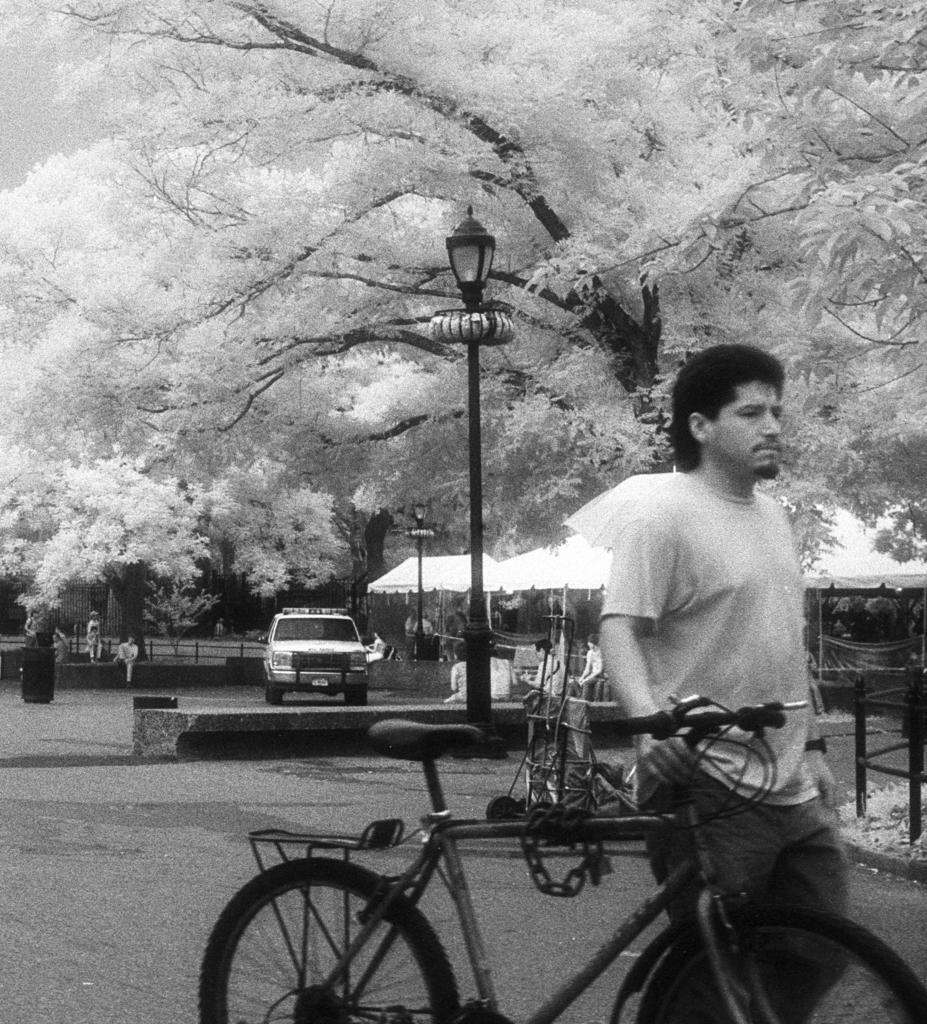How would you summarize this image in a sentence or two? This image is a black and white image. This image is taken outdoors. At the bottom of the image there is a road. On the right side of the image a man is walking on the road and he is holding a bicycle in his hand. In the middle of the image a car is parked on the road. There is a street light and a few people are sitting on the bench. There are a few stalls. In the background there are many trees. 